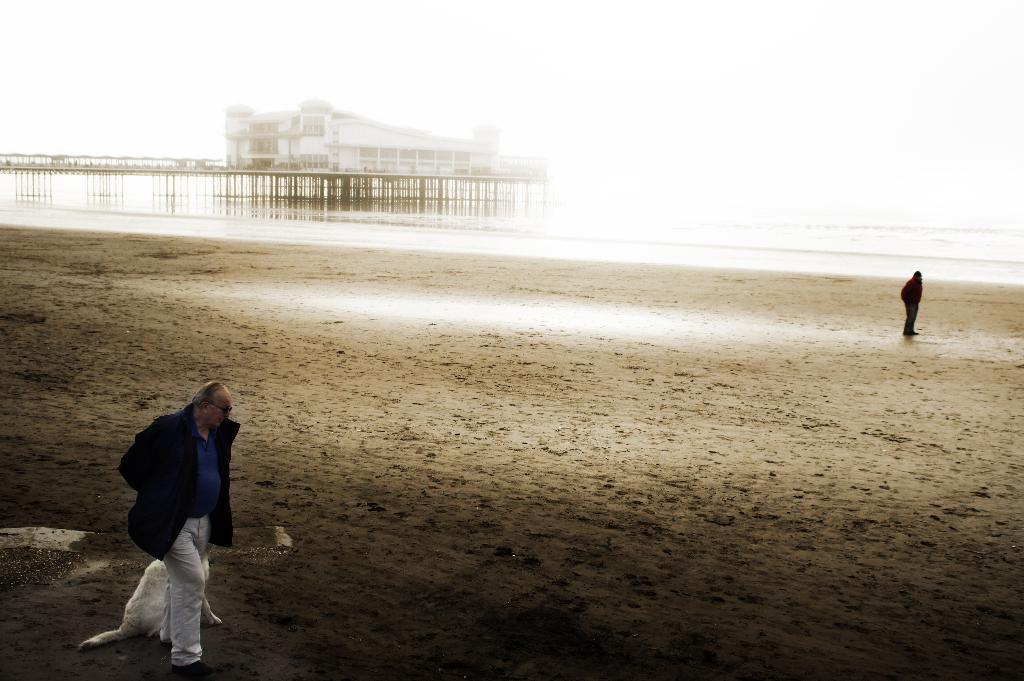What is located on the left side of the image? There is a man on the left side of the image. What is behind the man? There is a dog behind the man. What is on the right side of the image? There is a person on the right side of the image. What can be seen in the middle of the image? There is a bridge, a house, water, and sand in the middle of the image. What is the man's grandfather doing in the image? There is no mention of a grandfather in the image, so it is not possible to answer that question. Are there any slaves present in the image? There is no mention of slaves in the image, so it is not possible to answer that question. 